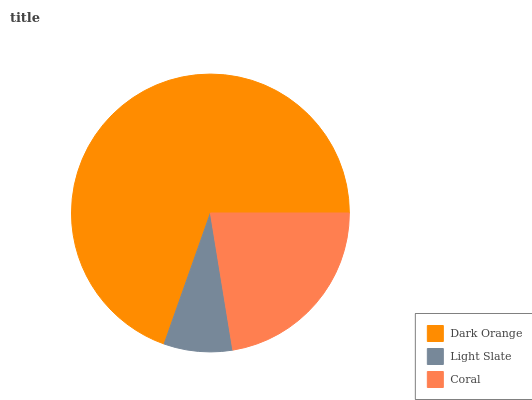Is Light Slate the minimum?
Answer yes or no. Yes. Is Dark Orange the maximum?
Answer yes or no. Yes. Is Coral the minimum?
Answer yes or no. No. Is Coral the maximum?
Answer yes or no. No. Is Coral greater than Light Slate?
Answer yes or no. Yes. Is Light Slate less than Coral?
Answer yes or no. Yes. Is Light Slate greater than Coral?
Answer yes or no. No. Is Coral less than Light Slate?
Answer yes or no. No. Is Coral the high median?
Answer yes or no. Yes. Is Coral the low median?
Answer yes or no. Yes. Is Light Slate the high median?
Answer yes or no. No. Is Dark Orange the low median?
Answer yes or no. No. 